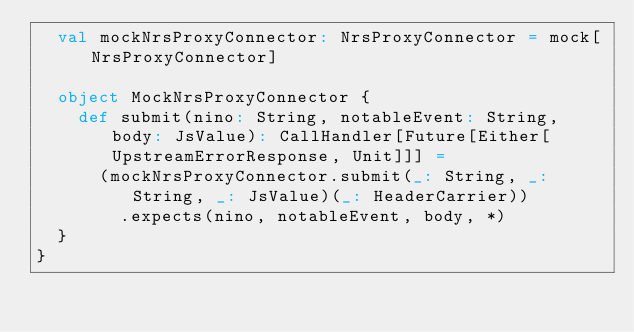Convert code to text. <code><loc_0><loc_0><loc_500><loc_500><_Scala_>  val mockNrsProxyConnector: NrsProxyConnector = mock[NrsProxyConnector]

  object MockNrsProxyConnector {
    def submit(nino: String, notableEvent: String, body: JsValue): CallHandler[Future[Either[UpstreamErrorResponse, Unit]]] =
      (mockNrsProxyConnector.submit(_: String, _: String, _: JsValue)(_: HeaderCarrier))
        .expects(nino, notableEvent, body, *)
  }
}
</code> 